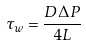Convert formula to latex. <formula><loc_0><loc_0><loc_500><loc_500>\tau _ { w } = \frac { D \Delta P } { 4 L }</formula> 